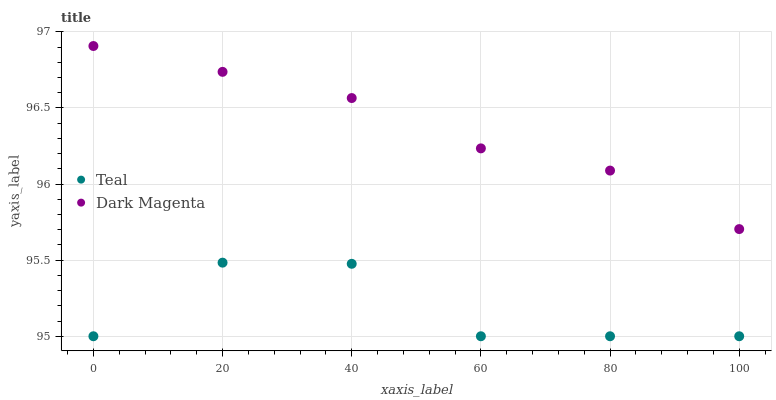Does Teal have the minimum area under the curve?
Answer yes or no. Yes. Does Dark Magenta have the maximum area under the curve?
Answer yes or no. Yes. Does Teal have the maximum area under the curve?
Answer yes or no. No. Is Dark Magenta the smoothest?
Answer yes or no. Yes. Is Teal the roughest?
Answer yes or no. Yes. Is Teal the smoothest?
Answer yes or no. No. Does Teal have the lowest value?
Answer yes or no. Yes. Does Dark Magenta have the highest value?
Answer yes or no. Yes. Does Teal have the highest value?
Answer yes or no. No. Is Teal less than Dark Magenta?
Answer yes or no. Yes. Is Dark Magenta greater than Teal?
Answer yes or no. Yes. Does Teal intersect Dark Magenta?
Answer yes or no. No. 